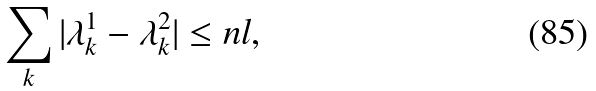<formula> <loc_0><loc_0><loc_500><loc_500>\sum _ { k } | \lambda ^ { 1 } _ { k } - \lambda ^ { 2 } _ { k } | \leq n l ,</formula> 